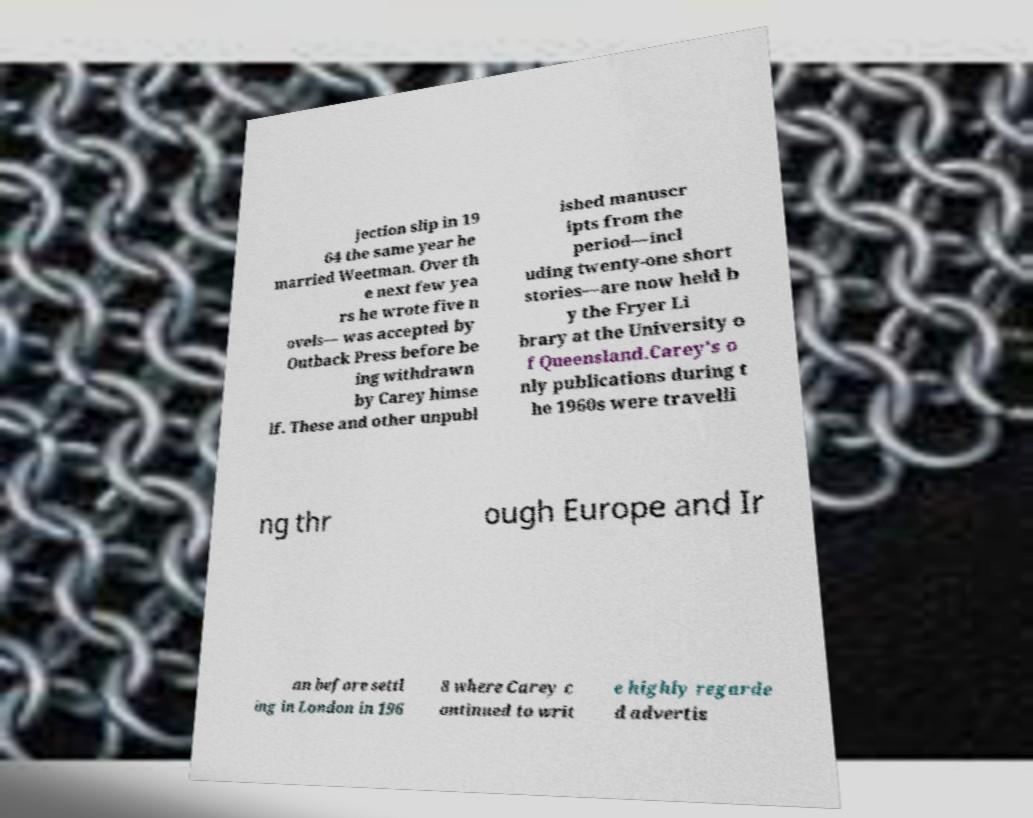Can you read and provide the text displayed in the image?This photo seems to have some interesting text. Can you extract and type it out for me? jection slip in 19 64 the same year he married Weetman. Over th e next few yea rs he wrote five n ovels— was accepted by Outback Press before be ing withdrawn by Carey himse lf. These and other unpubl ished manuscr ipts from the period—incl uding twenty-one short stories—are now held b y the Fryer Li brary at the University o f Queensland.Carey's o nly publications during t he 1960s were travelli ng thr ough Europe and Ir an before settl ing in London in 196 8 where Carey c ontinued to writ e highly regarde d advertis 